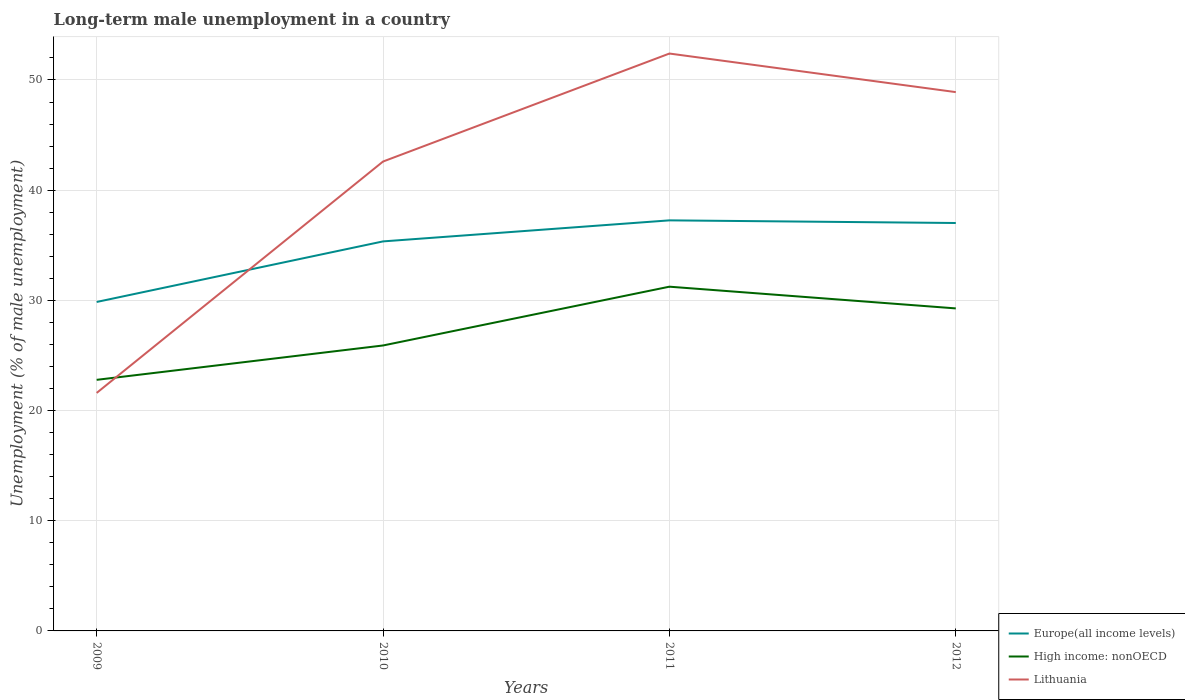Does the line corresponding to Lithuania intersect with the line corresponding to High income: nonOECD?
Offer a terse response. Yes. Is the number of lines equal to the number of legend labels?
Provide a succinct answer. Yes. Across all years, what is the maximum percentage of long-term unemployed male population in Europe(all income levels)?
Provide a short and direct response. 29.85. In which year was the percentage of long-term unemployed male population in High income: nonOECD maximum?
Offer a very short reply. 2009. What is the total percentage of long-term unemployed male population in Europe(all income levels) in the graph?
Offer a terse response. -1.91. What is the difference between the highest and the second highest percentage of long-term unemployed male population in Lithuania?
Your answer should be very brief. 30.8. Is the percentage of long-term unemployed male population in Lithuania strictly greater than the percentage of long-term unemployed male population in High income: nonOECD over the years?
Offer a very short reply. No. How many years are there in the graph?
Provide a succinct answer. 4. Are the values on the major ticks of Y-axis written in scientific E-notation?
Keep it short and to the point. No. Does the graph contain grids?
Your answer should be very brief. Yes. How many legend labels are there?
Offer a very short reply. 3. What is the title of the graph?
Your response must be concise. Long-term male unemployment in a country. Does "Oman" appear as one of the legend labels in the graph?
Offer a very short reply. No. What is the label or title of the Y-axis?
Your answer should be compact. Unemployment (% of male unemployment). What is the Unemployment (% of male unemployment) in Europe(all income levels) in 2009?
Keep it short and to the point. 29.85. What is the Unemployment (% of male unemployment) in High income: nonOECD in 2009?
Your answer should be compact. 22.79. What is the Unemployment (% of male unemployment) of Lithuania in 2009?
Your answer should be compact. 21.6. What is the Unemployment (% of male unemployment) of Europe(all income levels) in 2010?
Your answer should be compact. 35.35. What is the Unemployment (% of male unemployment) of High income: nonOECD in 2010?
Provide a succinct answer. 25.91. What is the Unemployment (% of male unemployment) of Lithuania in 2010?
Give a very brief answer. 42.6. What is the Unemployment (% of male unemployment) of Europe(all income levels) in 2011?
Offer a very short reply. 37.26. What is the Unemployment (% of male unemployment) in High income: nonOECD in 2011?
Offer a very short reply. 31.24. What is the Unemployment (% of male unemployment) of Lithuania in 2011?
Your answer should be compact. 52.4. What is the Unemployment (% of male unemployment) in Europe(all income levels) in 2012?
Your answer should be compact. 37.02. What is the Unemployment (% of male unemployment) of High income: nonOECD in 2012?
Your answer should be very brief. 29.27. What is the Unemployment (% of male unemployment) in Lithuania in 2012?
Your response must be concise. 48.9. Across all years, what is the maximum Unemployment (% of male unemployment) of Europe(all income levels)?
Provide a short and direct response. 37.26. Across all years, what is the maximum Unemployment (% of male unemployment) of High income: nonOECD?
Offer a very short reply. 31.24. Across all years, what is the maximum Unemployment (% of male unemployment) in Lithuania?
Provide a short and direct response. 52.4. Across all years, what is the minimum Unemployment (% of male unemployment) of Europe(all income levels)?
Make the answer very short. 29.85. Across all years, what is the minimum Unemployment (% of male unemployment) in High income: nonOECD?
Ensure brevity in your answer.  22.79. Across all years, what is the minimum Unemployment (% of male unemployment) of Lithuania?
Your answer should be very brief. 21.6. What is the total Unemployment (% of male unemployment) of Europe(all income levels) in the graph?
Ensure brevity in your answer.  139.49. What is the total Unemployment (% of male unemployment) in High income: nonOECD in the graph?
Your answer should be very brief. 109.2. What is the total Unemployment (% of male unemployment) in Lithuania in the graph?
Your answer should be compact. 165.5. What is the difference between the Unemployment (% of male unemployment) in Europe(all income levels) in 2009 and that in 2010?
Your answer should be very brief. -5.5. What is the difference between the Unemployment (% of male unemployment) of High income: nonOECD in 2009 and that in 2010?
Give a very brief answer. -3.12. What is the difference between the Unemployment (% of male unemployment) in Europe(all income levels) in 2009 and that in 2011?
Ensure brevity in your answer.  -7.41. What is the difference between the Unemployment (% of male unemployment) of High income: nonOECD in 2009 and that in 2011?
Give a very brief answer. -8.45. What is the difference between the Unemployment (% of male unemployment) in Lithuania in 2009 and that in 2011?
Keep it short and to the point. -30.8. What is the difference between the Unemployment (% of male unemployment) of Europe(all income levels) in 2009 and that in 2012?
Provide a short and direct response. -7.17. What is the difference between the Unemployment (% of male unemployment) of High income: nonOECD in 2009 and that in 2012?
Offer a terse response. -6.48. What is the difference between the Unemployment (% of male unemployment) of Lithuania in 2009 and that in 2012?
Give a very brief answer. -27.3. What is the difference between the Unemployment (% of male unemployment) of Europe(all income levels) in 2010 and that in 2011?
Your response must be concise. -1.91. What is the difference between the Unemployment (% of male unemployment) in High income: nonOECD in 2010 and that in 2011?
Provide a succinct answer. -5.34. What is the difference between the Unemployment (% of male unemployment) of Lithuania in 2010 and that in 2011?
Your answer should be compact. -9.8. What is the difference between the Unemployment (% of male unemployment) of Europe(all income levels) in 2010 and that in 2012?
Provide a short and direct response. -1.67. What is the difference between the Unemployment (% of male unemployment) in High income: nonOECD in 2010 and that in 2012?
Make the answer very short. -3.36. What is the difference between the Unemployment (% of male unemployment) in Europe(all income levels) in 2011 and that in 2012?
Offer a very short reply. 0.24. What is the difference between the Unemployment (% of male unemployment) of High income: nonOECD in 2011 and that in 2012?
Make the answer very short. 1.97. What is the difference between the Unemployment (% of male unemployment) in Europe(all income levels) in 2009 and the Unemployment (% of male unemployment) in High income: nonOECD in 2010?
Give a very brief answer. 3.95. What is the difference between the Unemployment (% of male unemployment) of Europe(all income levels) in 2009 and the Unemployment (% of male unemployment) of Lithuania in 2010?
Provide a short and direct response. -12.75. What is the difference between the Unemployment (% of male unemployment) in High income: nonOECD in 2009 and the Unemployment (% of male unemployment) in Lithuania in 2010?
Your answer should be compact. -19.81. What is the difference between the Unemployment (% of male unemployment) of Europe(all income levels) in 2009 and the Unemployment (% of male unemployment) of High income: nonOECD in 2011?
Make the answer very short. -1.39. What is the difference between the Unemployment (% of male unemployment) in Europe(all income levels) in 2009 and the Unemployment (% of male unemployment) in Lithuania in 2011?
Keep it short and to the point. -22.55. What is the difference between the Unemployment (% of male unemployment) in High income: nonOECD in 2009 and the Unemployment (% of male unemployment) in Lithuania in 2011?
Your answer should be very brief. -29.61. What is the difference between the Unemployment (% of male unemployment) in Europe(all income levels) in 2009 and the Unemployment (% of male unemployment) in High income: nonOECD in 2012?
Offer a terse response. 0.58. What is the difference between the Unemployment (% of male unemployment) in Europe(all income levels) in 2009 and the Unemployment (% of male unemployment) in Lithuania in 2012?
Give a very brief answer. -19.05. What is the difference between the Unemployment (% of male unemployment) in High income: nonOECD in 2009 and the Unemployment (% of male unemployment) in Lithuania in 2012?
Offer a very short reply. -26.11. What is the difference between the Unemployment (% of male unemployment) of Europe(all income levels) in 2010 and the Unemployment (% of male unemployment) of High income: nonOECD in 2011?
Offer a very short reply. 4.11. What is the difference between the Unemployment (% of male unemployment) of Europe(all income levels) in 2010 and the Unemployment (% of male unemployment) of Lithuania in 2011?
Your response must be concise. -17.05. What is the difference between the Unemployment (% of male unemployment) of High income: nonOECD in 2010 and the Unemployment (% of male unemployment) of Lithuania in 2011?
Provide a succinct answer. -26.49. What is the difference between the Unemployment (% of male unemployment) of Europe(all income levels) in 2010 and the Unemployment (% of male unemployment) of High income: nonOECD in 2012?
Provide a short and direct response. 6.08. What is the difference between the Unemployment (% of male unemployment) in Europe(all income levels) in 2010 and the Unemployment (% of male unemployment) in Lithuania in 2012?
Make the answer very short. -13.55. What is the difference between the Unemployment (% of male unemployment) in High income: nonOECD in 2010 and the Unemployment (% of male unemployment) in Lithuania in 2012?
Make the answer very short. -22.99. What is the difference between the Unemployment (% of male unemployment) in Europe(all income levels) in 2011 and the Unemployment (% of male unemployment) in High income: nonOECD in 2012?
Make the answer very short. 7.99. What is the difference between the Unemployment (% of male unemployment) in Europe(all income levels) in 2011 and the Unemployment (% of male unemployment) in Lithuania in 2012?
Keep it short and to the point. -11.64. What is the difference between the Unemployment (% of male unemployment) of High income: nonOECD in 2011 and the Unemployment (% of male unemployment) of Lithuania in 2012?
Ensure brevity in your answer.  -17.66. What is the average Unemployment (% of male unemployment) of Europe(all income levels) per year?
Keep it short and to the point. 34.87. What is the average Unemployment (% of male unemployment) in High income: nonOECD per year?
Offer a very short reply. 27.3. What is the average Unemployment (% of male unemployment) of Lithuania per year?
Your response must be concise. 41.38. In the year 2009, what is the difference between the Unemployment (% of male unemployment) in Europe(all income levels) and Unemployment (% of male unemployment) in High income: nonOECD?
Give a very brief answer. 7.07. In the year 2009, what is the difference between the Unemployment (% of male unemployment) in Europe(all income levels) and Unemployment (% of male unemployment) in Lithuania?
Make the answer very short. 8.25. In the year 2009, what is the difference between the Unemployment (% of male unemployment) in High income: nonOECD and Unemployment (% of male unemployment) in Lithuania?
Your response must be concise. 1.19. In the year 2010, what is the difference between the Unemployment (% of male unemployment) of Europe(all income levels) and Unemployment (% of male unemployment) of High income: nonOECD?
Your response must be concise. 9.45. In the year 2010, what is the difference between the Unemployment (% of male unemployment) in Europe(all income levels) and Unemployment (% of male unemployment) in Lithuania?
Your response must be concise. -7.25. In the year 2010, what is the difference between the Unemployment (% of male unemployment) of High income: nonOECD and Unemployment (% of male unemployment) of Lithuania?
Provide a succinct answer. -16.69. In the year 2011, what is the difference between the Unemployment (% of male unemployment) of Europe(all income levels) and Unemployment (% of male unemployment) of High income: nonOECD?
Provide a succinct answer. 6.02. In the year 2011, what is the difference between the Unemployment (% of male unemployment) in Europe(all income levels) and Unemployment (% of male unemployment) in Lithuania?
Offer a very short reply. -15.14. In the year 2011, what is the difference between the Unemployment (% of male unemployment) of High income: nonOECD and Unemployment (% of male unemployment) of Lithuania?
Your response must be concise. -21.16. In the year 2012, what is the difference between the Unemployment (% of male unemployment) of Europe(all income levels) and Unemployment (% of male unemployment) of High income: nonOECD?
Your answer should be very brief. 7.75. In the year 2012, what is the difference between the Unemployment (% of male unemployment) of Europe(all income levels) and Unemployment (% of male unemployment) of Lithuania?
Provide a succinct answer. -11.88. In the year 2012, what is the difference between the Unemployment (% of male unemployment) in High income: nonOECD and Unemployment (% of male unemployment) in Lithuania?
Provide a succinct answer. -19.63. What is the ratio of the Unemployment (% of male unemployment) in Europe(all income levels) in 2009 to that in 2010?
Offer a terse response. 0.84. What is the ratio of the Unemployment (% of male unemployment) of High income: nonOECD in 2009 to that in 2010?
Provide a short and direct response. 0.88. What is the ratio of the Unemployment (% of male unemployment) in Lithuania in 2009 to that in 2010?
Offer a very short reply. 0.51. What is the ratio of the Unemployment (% of male unemployment) of Europe(all income levels) in 2009 to that in 2011?
Provide a succinct answer. 0.8. What is the ratio of the Unemployment (% of male unemployment) of High income: nonOECD in 2009 to that in 2011?
Ensure brevity in your answer.  0.73. What is the ratio of the Unemployment (% of male unemployment) in Lithuania in 2009 to that in 2011?
Provide a short and direct response. 0.41. What is the ratio of the Unemployment (% of male unemployment) in Europe(all income levels) in 2009 to that in 2012?
Make the answer very short. 0.81. What is the ratio of the Unemployment (% of male unemployment) in High income: nonOECD in 2009 to that in 2012?
Ensure brevity in your answer.  0.78. What is the ratio of the Unemployment (% of male unemployment) in Lithuania in 2009 to that in 2012?
Your answer should be compact. 0.44. What is the ratio of the Unemployment (% of male unemployment) in Europe(all income levels) in 2010 to that in 2011?
Ensure brevity in your answer.  0.95. What is the ratio of the Unemployment (% of male unemployment) in High income: nonOECD in 2010 to that in 2011?
Ensure brevity in your answer.  0.83. What is the ratio of the Unemployment (% of male unemployment) of Lithuania in 2010 to that in 2011?
Offer a terse response. 0.81. What is the ratio of the Unemployment (% of male unemployment) in Europe(all income levels) in 2010 to that in 2012?
Offer a terse response. 0.95. What is the ratio of the Unemployment (% of male unemployment) in High income: nonOECD in 2010 to that in 2012?
Your answer should be compact. 0.89. What is the ratio of the Unemployment (% of male unemployment) in Lithuania in 2010 to that in 2012?
Provide a succinct answer. 0.87. What is the ratio of the Unemployment (% of male unemployment) of Europe(all income levels) in 2011 to that in 2012?
Your response must be concise. 1.01. What is the ratio of the Unemployment (% of male unemployment) in High income: nonOECD in 2011 to that in 2012?
Your answer should be very brief. 1.07. What is the ratio of the Unemployment (% of male unemployment) in Lithuania in 2011 to that in 2012?
Make the answer very short. 1.07. What is the difference between the highest and the second highest Unemployment (% of male unemployment) in Europe(all income levels)?
Keep it short and to the point. 0.24. What is the difference between the highest and the second highest Unemployment (% of male unemployment) in High income: nonOECD?
Offer a very short reply. 1.97. What is the difference between the highest and the lowest Unemployment (% of male unemployment) in Europe(all income levels)?
Your answer should be very brief. 7.41. What is the difference between the highest and the lowest Unemployment (% of male unemployment) of High income: nonOECD?
Provide a short and direct response. 8.45. What is the difference between the highest and the lowest Unemployment (% of male unemployment) in Lithuania?
Keep it short and to the point. 30.8. 